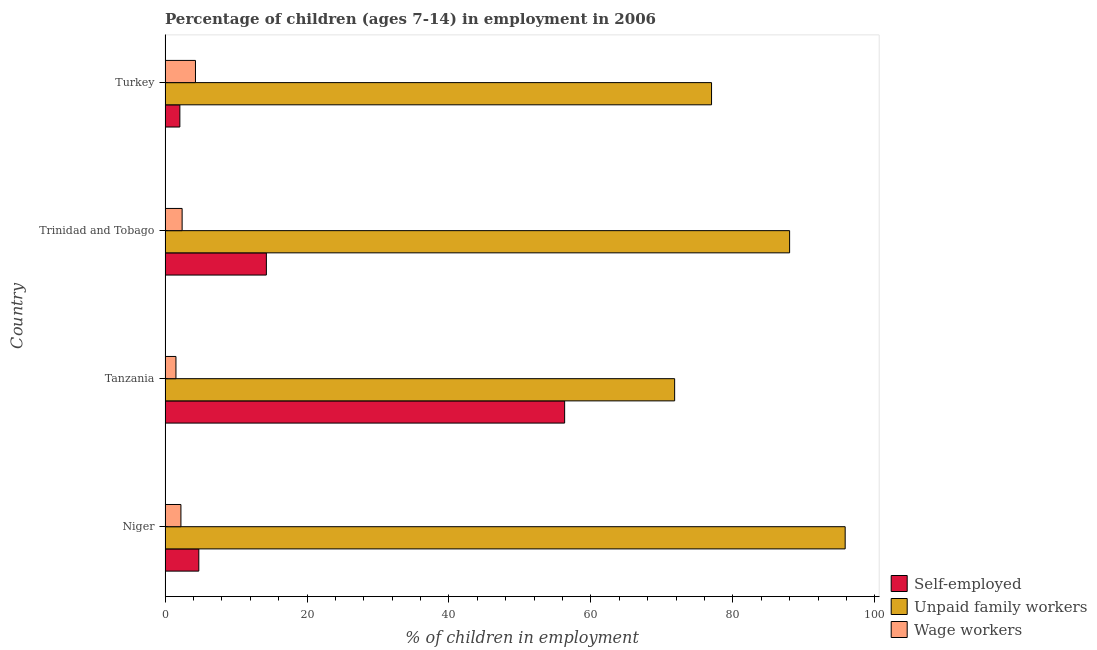How many groups of bars are there?
Offer a very short reply. 4. Are the number of bars on each tick of the Y-axis equal?
Give a very brief answer. Yes. What is the label of the 1st group of bars from the top?
Provide a short and direct response. Turkey. In how many cases, is the number of bars for a given country not equal to the number of legend labels?
Offer a very short reply. 0. What is the percentage of self employed children in Trinidad and Tobago?
Give a very brief answer. 14.27. Across all countries, what is the maximum percentage of children employed as wage workers?
Your response must be concise. 4.28. Across all countries, what is the minimum percentage of children employed as wage workers?
Your answer should be compact. 1.53. In which country was the percentage of self employed children maximum?
Provide a succinct answer. Tanzania. What is the total percentage of children employed as unpaid family workers in the graph?
Provide a short and direct response. 332.63. What is the difference between the percentage of self employed children in Niger and that in Trinidad and Tobago?
Offer a very short reply. -9.52. What is the difference between the percentage of children employed as wage workers in Tanzania and the percentage of self employed children in Niger?
Provide a succinct answer. -3.22. What is the average percentage of children employed as wage workers per country?
Your answer should be compact. 2.61. What is the difference between the percentage of children employed as wage workers and percentage of children employed as unpaid family workers in Trinidad and Tobago?
Give a very brief answer. -85.6. In how many countries, is the percentage of children employed as wage workers greater than 52 %?
Give a very brief answer. 0. What is the ratio of the percentage of children employed as wage workers in Niger to that in Turkey?
Your answer should be compact. 0.52. Is the difference between the percentage of children employed as unpaid family workers in Tanzania and Turkey greater than the difference between the percentage of self employed children in Tanzania and Turkey?
Your answer should be compact. No. What is the difference between the highest and the second highest percentage of self employed children?
Your answer should be very brief. 42.03. What is the difference between the highest and the lowest percentage of children employed as unpaid family workers?
Keep it short and to the point. 24.03. In how many countries, is the percentage of self employed children greater than the average percentage of self employed children taken over all countries?
Give a very brief answer. 1. Is the sum of the percentage of children employed as wage workers in Niger and Tanzania greater than the maximum percentage of self employed children across all countries?
Ensure brevity in your answer.  No. What does the 2nd bar from the top in Trinidad and Tobago represents?
Your answer should be compact. Unpaid family workers. What does the 1st bar from the bottom in Trinidad and Tobago represents?
Offer a very short reply. Self-employed. Is it the case that in every country, the sum of the percentage of self employed children and percentage of children employed as unpaid family workers is greater than the percentage of children employed as wage workers?
Offer a terse response. Yes. How many bars are there?
Offer a very short reply. 12. How many countries are there in the graph?
Provide a short and direct response. 4. What is the difference between two consecutive major ticks on the X-axis?
Provide a succinct answer. 20. Does the graph contain any zero values?
Keep it short and to the point. No. How are the legend labels stacked?
Keep it short and to the point. Vertical. What is the title of the graph?
Offer a terse response. Percentage of children (ages 7-14) in employment in 2006. What is the label or title of the X-axis?
Ensure brevity in your answer.  % of children in employment. What is the % of children in employment in Self-employed in Niger?
Make the answer very short. 4.75. What is the % of children in employment of Unpaid family workers in Niger?
Provide a short and direct response. 95.83. What is the % of children in employment in Wage workers in Niger?
Provide a succinct answer. 2.23. What is the % of children in employment in Self-employed in Tanzania?
Provide a short and direct response. 56.3. What is the % of children in employment in Unpaid family workers in Tanzania?
Make the answer very short. 71.8. What is the % of children in employment of Wage workers in Tanzania?
Give a very brief answer. 1.53. What is the % of children in employment of Self-employed in Trinidad and Tobago?
Keep it short and to the point. 14.27. What is the % of children in employment in Unpaid family workers in Trinidad and Tobago?
Make the answer very short. 88. What is the % of children in employment in Self-employed in Turkey?
Make the answer very short. 2.08. What is the % of children in employment in Unpaid family workers in Turkey?
Keep it short and to the point. 77. What is the % of children in employment in Wage workers in Turkey?
Your response must be concise. 4.28. Across all countries, what is the maximum % of children in employment in Self-employed?
Offer a terse response. 56.3. Across all countries, what is the maximum % of children in employment in Unpaid family workers?
Your response must be concise. 95.83. Across all countries, what is the maximum % of children in employment in Wage workers?
Provide a short and direct response. 4.28. Across all countries, what is the minimum % of children in employment of Self-employed?
Offer a very short reply. 2.08. Across all countries, what is the minimum % of children in employment of Unpaid family workers?
Make the answer very short. 71.8. Across all countries, what is the minimum % of children in employment in Wage workers?
Keep it short and to the point. 1.53. What is the total % of children in employment in Self-employed in the graph?
Keep it short and to the point. 77.4. What is the total % of children in employment of Unpaid family workers in the graph?
Give a very brief answer. 332.63. What is the total % of children in employment in Wage workers in the graph?
Your answer should be very brief. 10.44. What is the difference between the % of children in employment of Self-employed in Niger and that in Tanzania?
Keep it short and to the point. -51.55. What is the difference between the % of children in employment in Unpaid family workers in Niger and that in Tanzania?
Provide a succinct answer. 24.03. What is the difference between the % of children in employment of Self-employed in Niger and that in Trinidad and Tobago?
Give a very brief answer. -9.52. What is the difference between the % of children in employment of Unpaid family workers in Niger and that in Trinidad and Tobago?
Your answer should be compact. 7.83. What is the difference between the % of children in employment in Wage workers in Niger and that in Trinidad and Tobago?
Ensure brevity in your answer.  -0.17. What is the difference between the % of children in employment of Self-employed in Niger and that in Turkey?
Provide a short and direct response. 2.67. What is the difference between the % of children in employment in Unpaid family workers in Niger and that in Turkey?
Offer a terse response. 18.83. What is the difference between the % of children in employment in Wage workers in Niger and that in Turkey?
Keep it short and to the point. -2.05. What is the difference between the % of children in employment in Self-employed in Tanzania and that in Trinidad and Tobago?
Your response must be concise. 42.03. What is the difference between the % of children in employment in Unpaid family workers in Tanzania and that in Trinidad and Tobago?
Keep it short and to the point. -16.2. What is the difference between the % of children in employment of Wage workers in Tanzania and that in Trinidad and Tobago?
Your answer should be compact. -0.87. What is the difference between the % of children in employment of Self-employed in Tanzania and that in Turkey?
Provide a short and direct response. 54.22. What is the difference between the % of children in employment of Unpaid family workers in Tanzania and that in Turkey?
Provide a succinct answer. -5.2. What is the difference between the % of children in employment of Wage workers in Tanzania and that in Turkey?
Offer a terse response. -2.75. What is the difference between the % of children in employment of Self-employed in Trinidad and Tobago and that in Turkey?
Give a very brief answer. 12.19. What is the difference between the % of children in employment in Unpaid family workers in Trinidad and Tobago and that in Turkey?
Your answer should be very brief. 11. What is the difference between the % of children in employment of Wage workers in Trinidad and Tobago and that in Turkey?
Your answer should be compact. -1.88. What is the difference between the % of children in employment of Self-employed in Niger and the % of children in employment of Unpaid family workers in Tanzania?
Give a very brief answer. -67.05. What is the difference between the % of children in employment in Self-employed in Niger and the % of children in employment in Wage workers in Tanzania?
Your answer should be compact. 3.22. What is the difference between the % of children in employment of Unpaid family workers in Niger and the % of children in employment of Wage workers in Tanzania?
Your answer should be very brief. 94.3. What is the difference between the % of children in employment in Self-employed in Niger and the % of children in employment in Unpaid family workers in Trinidad and Tobago?
Your response must be concise. -83.25. What is the difference between the % of children in employment in Self-employed in Niger and the % of children in employment in Wage workers in Trinidad and Tobago?
Keep it short and to the point. 2.35. What is the difference between the % of children in employment of Unpaid family workers in Niger and the % of children in employment of Wage workers in Trinidad and Tobago?
Give a very brief answer. 93.43. What is the difference between the % of children in employment of Self-employed in Niger and the % of children in employment of Unpaid family workers in Turkey?
Your answer should be very brief. -72.25. What is the difference between the % of children in employment of Self-employed in Niger and the % of children in employment of Wage workers in Turkey?
Your answer should be very brief. 0.47. What is the difference between the % of children in employment in Unpaid family workers in Niger and the % of children in employment in Wage workers in Turkey?
Offer a very short reply. 91.55. What is the difference between the % of children in employment in Self-employed in Tanzania and the % of children in employment in Unpaid family workers in Trinidad and Tobago?
Offer a terse response. -31.7. What is the difference between the % of children in employment in Self-employed in Tanzania and the % of children in employment in Wage workers in Trinidad and Tobago?
Keep it short and to the point. 53.9. What is the difference between the % of children in employment in Unpaid family workers in Tanzania and the % of children in employment in Wage workers in Trinidad and Tobago?
Give a very brief answer. 69.4. What is the difference between the % of children in employment of Self-employed in Tanzania and the % of children in employment of Unpaid family workers in Turkey?
Offer a terse response. -20.7. What is the difference between the % of children in employment of Self-employed in Tanzania and the % of children in employment of Wage workers in Turkey?
Provide a succinct answer. 52.02. What is the difference between the % of children in employment of Unpaid family workers in Tanzania and the % of children in employment of Wage workers in Turkey?
Make the answer very short. 67.52. What is the difference between the % of children in employment in Self-employed in Trinidad and Tobago and the % of children in employment in Unpaid family workers in Turkey?
Keep it short and to the point. -62.73. What is the difference between the % of children in employment of Self-employed in Trinidad and Tobago and the % of children in employment of Wage workers in Turkey?
Offer a very short reply. 9.99. What is the difference between the % of children in employment of Unpaid family workers in Trinidad and Tobago and the % of children in employment of Wage workers in Turkey?
Provide a short and direct response. 83.72. What is the average % of children in employment in Self-employed per country?
Keep it short and to the point. 19.35. What is the average % of children in employment in Unpaid family workers per country?
Provide a succinct answer. 83.16. What is the average % of children in employment of Wage workers per country?
Make the answer very short. 2.61. What is the difference between the % of children in employment in Self-employed and % of children in employment in Unpaid family workers in Niger?
Your response must be concise. -91.08. What is the difference between the % of children in employment of Self-employed and % of children in employment of Wage workers in Niger?
Give a very brief answer. 2.52. What is the difference between the % of children in employment of Unpaid family workers and % of children in employment of Wage workers in Niger?
Give a very brief answer. 93.6. What is the difference between the % of children in employment in Self-employed and % of children in employment in Unpaid family workers in Tanzania?
Ensure brevity in your answer.  -15.5. What is the difference between the % of children in employment in Self-employed and % of children in employment in Wage workers in Tanzania?
Your answer should be compact. 54.77. What is the difference between the % of children in employment of Unpaid family workers and % of children in employment of Wage workers in Tanzania?
Your answer should be very brief. 70.27. What is the difference between the % of children in employment in Self-employed and % of children in employment in Unpaid family workers in Trinidad and Tobago?
Ensure brevity in your answer.  -73.73. What is the difference between the % of children in employment in Self-employed and % of children in employment in Wage workers in Trinidad and Tobago?
Give a very brief answer. 11.87. What is the difference between the % of children in employment in Unpaid family workers and % of children in employment in Wage workers in Trinidad and Tobago?
Keep it short and to the point. 85.6. What is the difference between the % of children in employment in Self-employed and % of children in employment in Unpaid family workers in Turkey?
Make the answer very short. -74.92. What is the difference between the % of children in employment of Self-employed and % of children in employment of Wage workers in Turkey?
Your response must be concise. -2.2. What is the difference between the % of children in employment of Unpaid family workers and % of children in employment of Wage workers in Turkey?
Your answer should be compact. 72.72. What is the ratio of the % of children in employment of Self-employed in Niger to that in Tanzania?
Ensure brevity in your answer.  0.08. What is the ratio of the % of children in employment in Unpaid family workers in Niger to that in Tanzania?
Keep it short and to the point. 1.33. What is the ratio of the % of children in employment of Wage workers in Niger to that in Tanzania?
Offer a terse response. 1.46. What is the ratio of the % of children in employment of Self-employed in Niger to that in Trinidad and Tobago?
Make the answer very short. 0.33. What is the ratio of the % of children in employment of Unpaid family workers in Niger to that in Trinidad and Tobago?
Your answer should be compact. 1.09. What is the ratio of the % of children in employment in Wage workers in Niger to that in Trinidad and Tobago?
Offer a terse response. 0.93. What is the ratio of the % of children in employment of Self-employed in Niger to that in Turkey?
Offer a very short reply. 2.28. What is the ratio of the % of children in employment of Unpaid family workers in Niger to that in Turkey?
Keep it short and to the point. 1.24. What is the ratio of the % of children in employment of Wage workers in Niger to that in Turkey?
Offer a terse response. 0.52. What is the ratio of the % of children in employment of Self-employed in Tanzania to that in Trinidad and Tobago?
Offer a terse response. 3.95. What is the ratio of the % of children in employment of Unpaid family workers in Tanzania to that in Trinidad and Tobago?
Ensure brevity in your answer.  0.82. What is the ratio of the % of children in employment in Wage workers in Tanzania to that in Trinidad and Tobago?
Ensure brevity in your answer.  0.64. What is the ratio of the % of children in employment of Self-employed in Tanzania to that in Turkey?
Keep it short and to the point. 27.07. What is the ratio of the % of children in employment of Unpaid family workers in Tanzania to that in Turkey?
Offer a very short reply. 0.93. What is the ratio of the % of children in employment in Wage workers in Tanzania to that in Turkey?
Your answer should be very brief. 0.36. What is the ratio of the % of children in employment of Self-employed in Trinidad and Tobago to that in Turkey?
Provide a short and direct response. 6.86. What is the ratio of the % of children in employment of Wage workers in Trinidad and Tobago to that in Turkey?
Your answer should be very brief. 0.56. What is the difference between the highest and the second highest % of children in employment in Self-employed?
Give a very brief answer. 42.03. What is the difference between the highest and the second highest % of children in employment of Unpaid family workers?
Provide a succinct answer. 7.83. What is the difference between the highest and the second highest % of children in employment of Wage workers?
Keep it short and to the point. 1.88. What is the difference between the highest and the lowest % of children in employment of Self-employed?
Make the answer very short. 54.22. What is the difference between the highest and the lowest % of children in employment in Unpaid family workers?
Make the answer very short. 24.03. What is the difference between the highest and the lowest % of children in employment in Wage workers?
Provide a short and direct response. 2.75. 